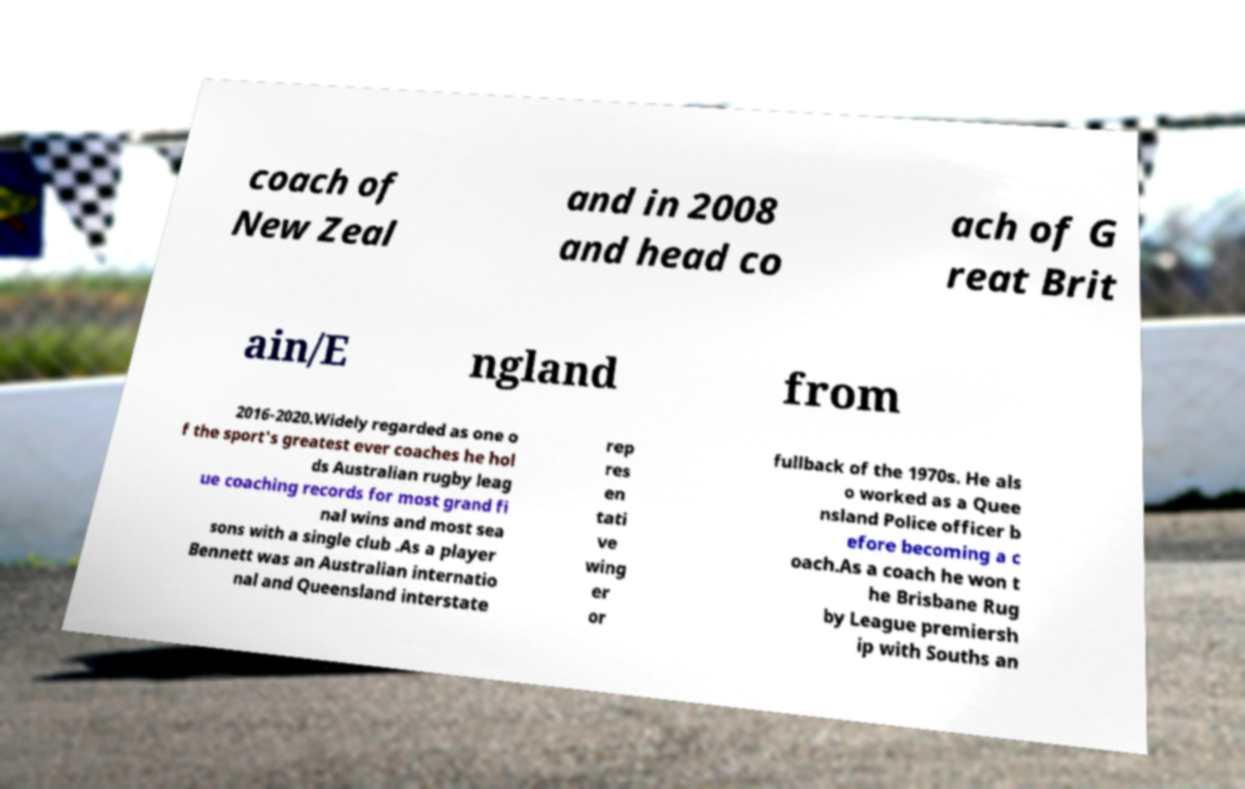Please identify and transcribe the text found in this image. coach of New Zeal and in 2008 and head co ach of G reat Brit ain/E ngland from 2016-2020.Widely regarded as one o f the sport's greatest ever coaches he hol ds Australian rugby leag ue coaching records for most grand fi nal wins and most sea sons with a single club .As a player Bennett was an Australian internatio nal and Queensland interstate rep res en tati ve wing er or fullback of the 1970s. He als o worked as a Quee nsland Police officer b efore becoming a c oach.As a coach he won t he Brisbane Rug by League premiersh ip with Souths an 